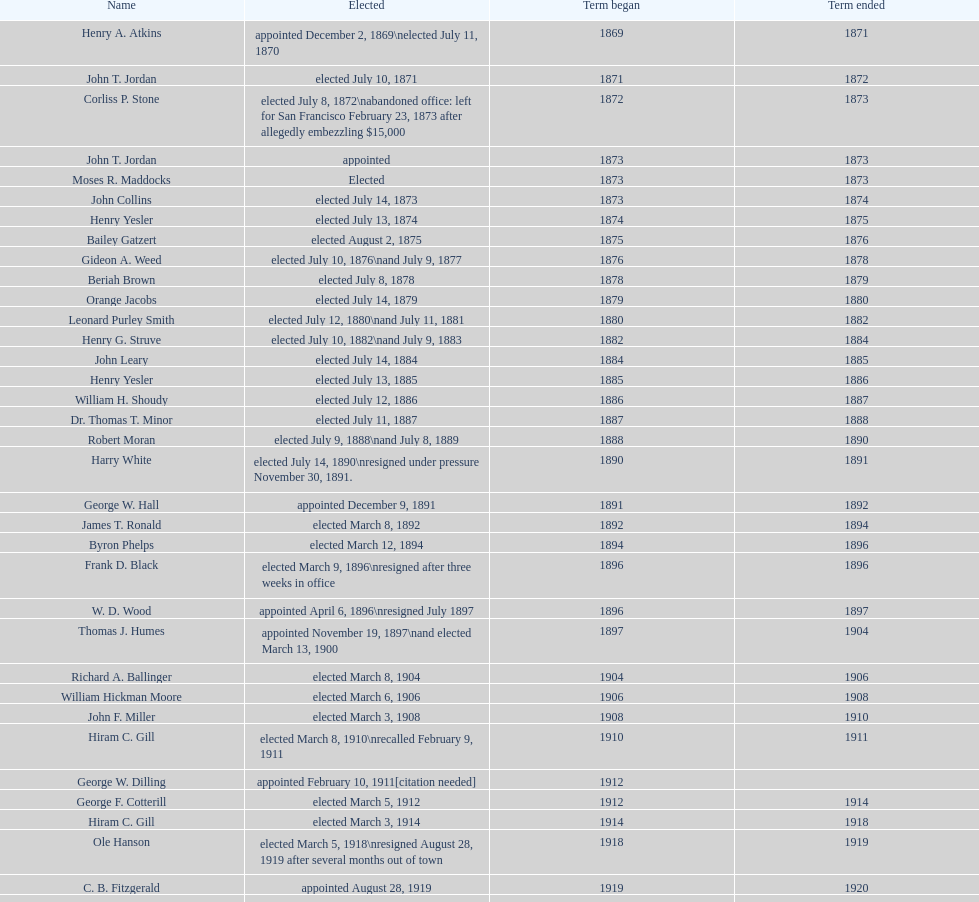Who started their period in 1890? Harry White. 